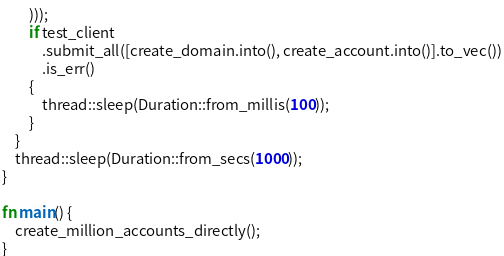Convert code to text. <code><loc_0><loc_0><loc_500><loc_500><_Rust_>        )));
        if test_client
            .submit_all([create_domain.into(), create_account.into()].to_vec())
            .is_err()
        {
            thread::sleep(Duration::from_millis(100));
        }
    }
    thread::sleep(Duration::from_secs(1000));
}

fn main() {
    create_million_accounts_directly();
}
</code> 